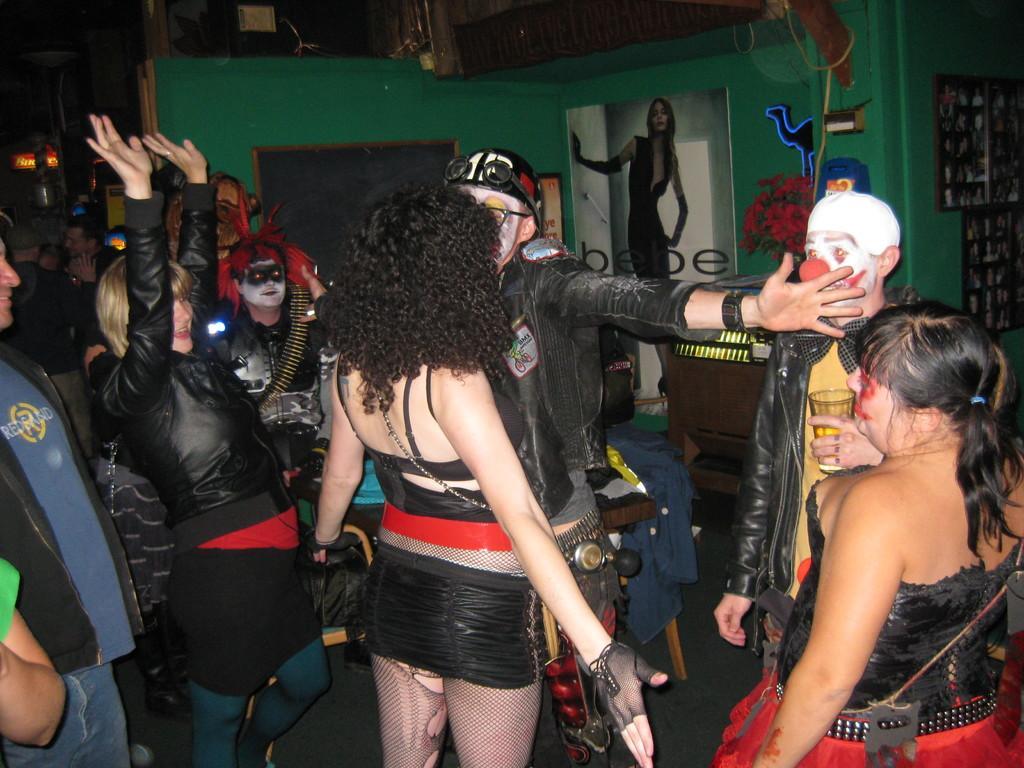In one or two sentences, can you explain what this image depicts? In the picture we can see inside the house with some people are with a different costumes and they are dancing and behind them, we can see a wall which is green in color and on it we can see a poster with an image of a woman and beside it we can see a photo frame and some flowers which are red in color. 